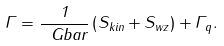Convert formula to latex. <formula><loc_0><loc_0><loc_500><loc_500>\Gamma = \frac { 1 } { \ G b a r } \left ( S _ { k i n } + S _ { w z } \right ) + \Gamma _ { q } .</formula> 